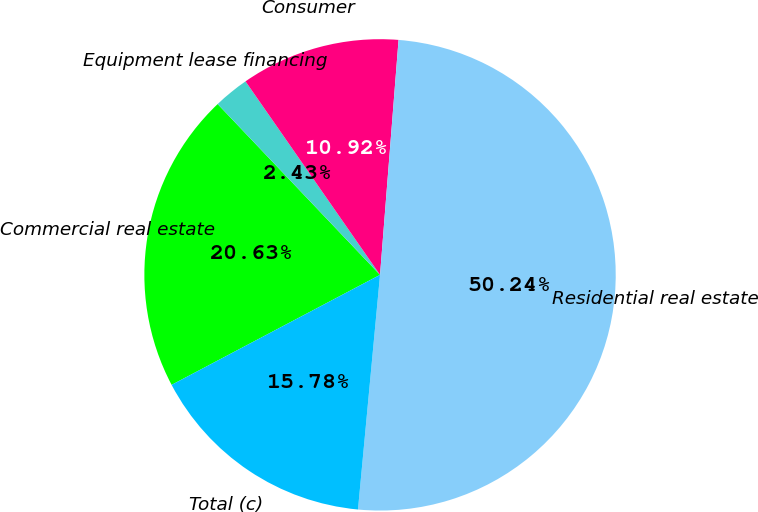<chart> <loc_0><loc_0><loc_500><loc_500><pie_chart><fcel>Commercial real estate<fcel>Equipment lease financing<fcel>Consumer<fcel>Residential real estate<fcel>Total (c)<nl><fcel>20.63%<fcel>2.43%<fcel>10.92%<fcel>50.24%<fcel>15.78%<nl></chart> 